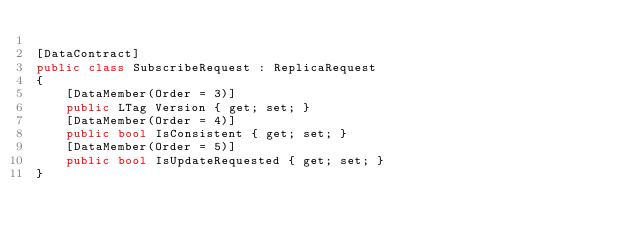<code> <loc_0><loc_0><loc_500><loc_500><_C#_>
[DataContract]
public class SubscribeRequest : ReplicaRequest
{
    [DataMember(Order = 3)]
    public LTag Version { get; set; }
    [DataMember(Order = 4)]
    public bool IsConsistent { get; set; }
    [DataMember(Order = 5)]
    public bool IsUpdateRequested { get; set; }
}
</code> 